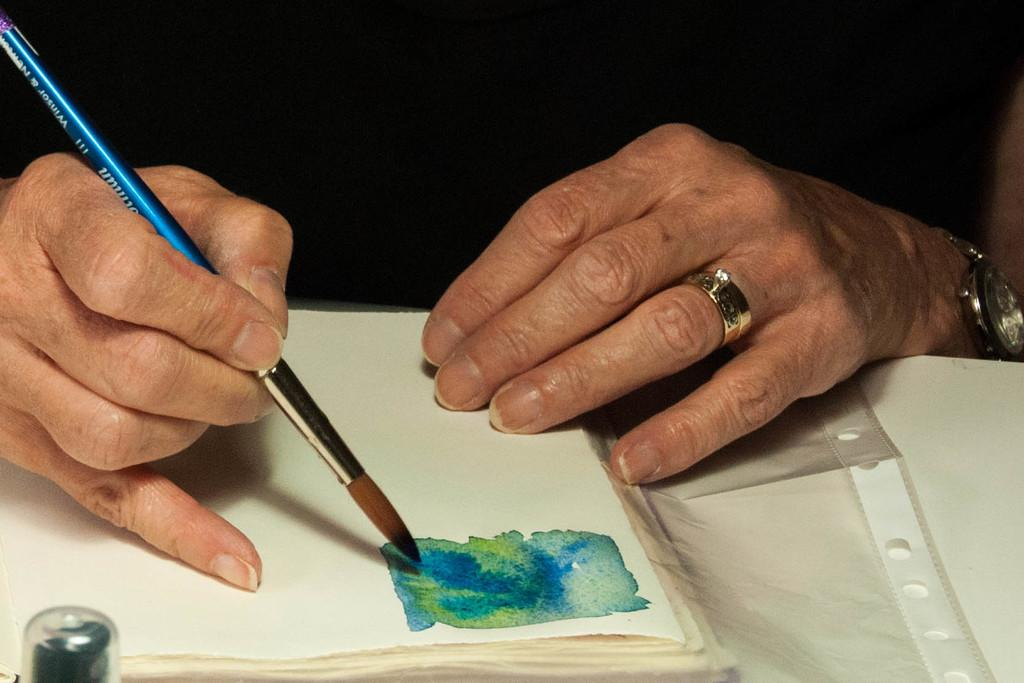What is the human hand holding in the image? The human hand is holding a paintbrush in the image. What can be seen on the table in the image? There are papers on the table in the image. How much meat is being measured on the table in the image? There is no meat present in the image; it features a human hand holding a paintbrush and papers on a table. 